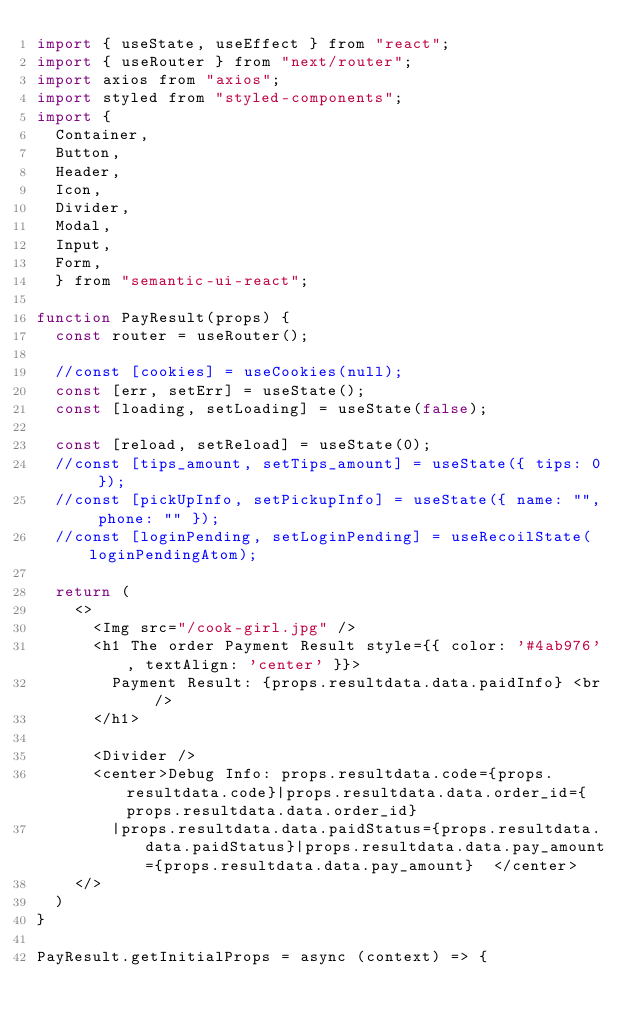Convert code to text. <code><loc_0><loc_0><loc_500><loc_500><_JavaScript_>import { useState, useEffect } from "react";
import { useRouter } from "next/router";
import axios from "axios";
import styled from "styled-components";
import {
	Container,
	Button,
	Header,
	Icon,
	Divider,
	Modal,
	Input,
	Form,
  } from "semantic-ui-react";

function PayResult(props) {
	const router = useRouter();
  
	//const [cookies] = useCookies(null);
	const [err, setErr] = useState();
	const [loading, setLoading] = useState(false);
	  
	const [reload, setReload] = useState(0);
	//const [tips_amount, setTips_amount] = useState({ tips: 0 });
	//const [pickUpInfo, setPickupInfo] = useState({ name: "", phone: "" });
	//const [loginPending, setLoginPending] = useRecoilState(loginPendingAtom);
  
	return (
		<>
			<Img src="/cook-girl.jpg" />
			<h1 The order Payment Result style={{ color: '#4ab976', textAlign: 'center' }}>
				Payment Result: {props.resultdata.data.paidInfo} <br />
			</h1>
			
			<Divider />
			<center>Debug Info: props.resultdata.code={props.resultdata.code}|props.resultdata.data.order_id={props.resultdata.data.order_id}
				|props.resultdata.data.paidStatus={props.resultdata.data.paidStatus}|props.resultdata.data.pay_amount={props.resultdata.data.pay_amount}  </center>
		</>
	)
}

PayResult.getInitialProps = async (context) => {</code> 